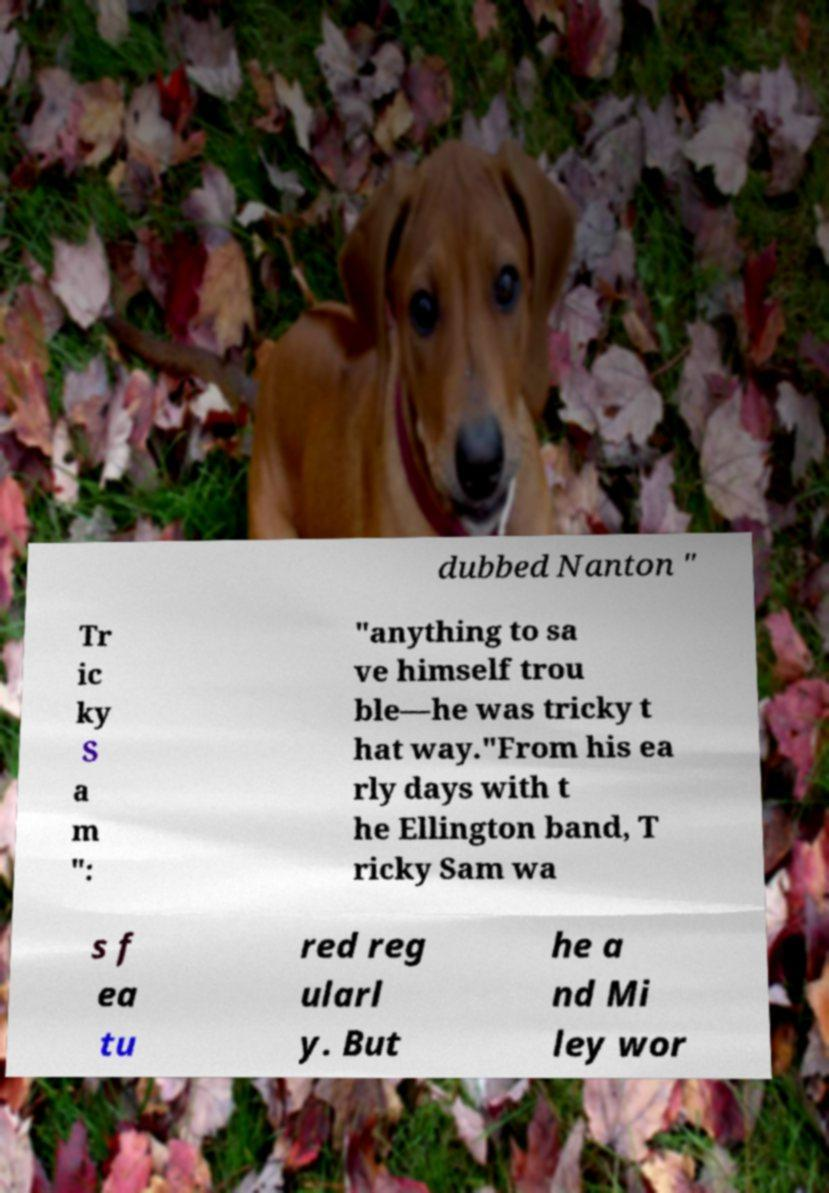Please read and relay the text visible in this image. What does it say? dubbed Nanton " Tr ic ky S a m ": "anything to sa ve himself trou ble—he was tricky t hat way."From his ea rly days with t he Ellington band, T ricky Sam wa s f ea tu red reg ularl y. But he a nd Mi ley wor 